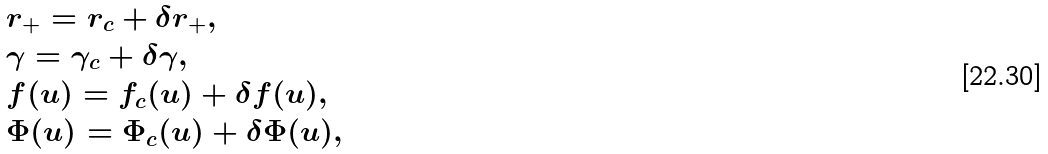<formula> <loc_0><loc_0><loc_500><loc_500>& r _ { + } = r _ { c } + \delta r _ { + } , \\ & \gamma = \gamma _ { c } + \delta \gamma , \\ & f ( u ) = f _ { c } ( u ) + \delta f ( u ) , \\ & \Phi ( u ) = \Phi _ { c } ( u ) + \delta \Phi ( u ) ,</formula> 